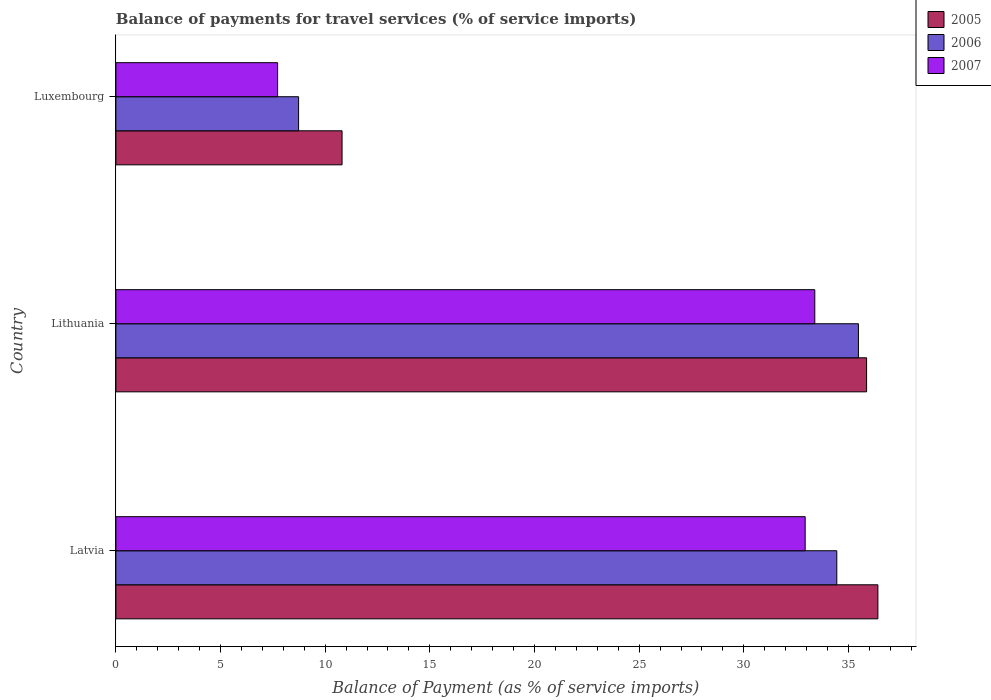How many groups of bars are there?
Your answer should be compact. 3. Are the number of bars per tick equal to the number of legend labels?
Your answer should be very brief. Yes. Are the number of bars on each tick of the Y-axis equal?
Provide a short and direct response. Yes. How many bars are there on the 2nd tick from the bottom?
Your response must be concise. 3. What is the label of the 2nd group of bars from the top?
Ensure brevity in your answer.  Lithuania. What is the balance of payments for travel services in 2005 in Luxembourg?
Provide a short and direct response. 10.81. Across all countries, what is the maximum balance of payments for travel services in 2006?
Your answer should be very brief. 35.48. Across all countries, what is the minimum balance of payments for travel services in 2005?
Provide a succinct answer. 10.81. In which country was the balance of payments for travel services in 2007 maximum?
Provide a succinct answer. Lithuania. In which country was the balance of payments for travel services in 2005 minimum?
Offer a terse response. Luxembourg. What is the total balance of payments for travel services in 2005 in the graph?
Ensure brevity in your answer.  83.08. What is the difference between the balance of payments for travel services in 2007 in Latvia and that in Luxembourg?
Offer a terse response. 25.21. What is the difference between the balance of payments for travel services in 2006 in Luxembourg and the balance of payments for travel services in 2007 in Lithuania?
Offer a very short reply. -24.66. What is the average balance of payments for travel services in 2007 per country?
Keep it short and to the point. 24.68. What is the difference between the balance of payments for travel services in 2007 and balance of payments for travel services in 2005 in Luxembourg?
Offer a very short reply. -3.08. In how many countries, is the balance of payments for travel services in 2005 greater than 3 %?
Provide a short and direct response. 3. What is the ratio of the balance of payments for travel services in 2005 in Latvia to that in Luxembourg?
Ensure brevity in your answer.  3.37. Is the balance of payments for travel services in 2005 in Latvia less than that in Luxembourg?
Offer a terse response. No. Is the difference between the balance of payments for travel services in 2007 in Latvia and Luxembourg greater than the difference between the balance of payments for travel services in 2005 in Latvia and Luxembourg?
Ensure brevity in your answer.  No. What is the difference between the highest and the second highest balance of payments for travel services in 2007?
Provide a short and direct response. 0.46. What is the difference between the highest and the lowest balance of payments for travel services in 2005?
Your answer should be very brief. 25.6. In how many countries, is the balance of payments for travel services in 2005 greater than the average balance of payments for travel services in 2005 taken over all countries?
Your answer should be very brief. 2. What does the 1st bar from the bottom in Luxembourg represents?
Your response must be concise. 2005. Is it the case that in every country, the sum of the balance of payments for travel services in 2006 and balance of payments for travel services in 2007 is greater than the balance of payments for travel services in 2005?
Keep it short and to the point. Yes. How many bars are there?
Keep it short and to the point. 9. Are all the bars in the graph horizontal?
Keep it short and to the point. Yes. How many countries are there in the graph?
Your answer should be compact. 3. What is the difference between two consecutive major ticks on the X-axis?
Give a very brief answer. 5. Are the values on the major ticks of X-axis written in scientific E-notation?
Provide a short and direct response. No. Does the graph contain any zero values?
Provide a succinct answer. No. Where does the legend appear in the graph?
Your answer should be compact. Top right. How many legend labels are there?
Offer a terse response. 3. What is the title of the graph?
Give a very brief answer. Balance of payments for travel services (% of service imports). Does "2009" appear as one of the legend labels in the graph?
Offer a terse response. No. What is the label or title of the X-axis?
Your response must be concise. Balance of Payment (as % of service imports). What is the label or title of the Y-axis?
Your answer should be compact. Country. What is the Balance of Payment (as % of service imports) of 2005 in Latvia?
Your answer should be very brief. 36.41. What is the Balance of Payment (as % of service imports) of 2006 in Latvia?
Provide a succinct answer. 34.44. What is the Balance of Payment (as % of service imports) in 2007 in Latvia?
Provide a succinct answer. 32.93. What is the Balance of Payment (as % of service imports) in 2005 in Lithuania?
Ensure brevity in your answer.  35.87. What is the Balance of Payment (as % of service imports) of 2006 in Lithuania?
Your response must be concise. 35.48. What is the Balance of Payment (as % of service imports) in 2007 in Lithuania?
Your response must be concise. 33.39. What is the Balance of Payment (as % of service imports) of 2005 in Luxembourg?
Offer a terse response. 10.81. What is the Balance of Payment (as % of service imports) in 2006 in Luxembourg?
Offer a very short reply. 8.73. What is the Balance of Payment (as % of service imports) of 2007 in Luxembourg?
Your answer should be compact. 7.73. Across all countries, what is the maximum Balance of Payment (as % of service imports) of 2005?
Provide a short and direct response. 36.41. Across all countries, what is the maximum Balance of Payment (as % of service imports) of 2006?
Ensure brevity in your answer.  35.48. Across all countries, what is the maximum Balance of Payment (as % of service imports) in 2007?
Provide a succinct answer. 33.39. Across all countries, what is the minimum Balance of Payment (as % of service imports) in 2005?
Give a very brief answer. 10.81. Across all countries, what is the minimum Balance of Payment (as % of service imports) in 2006?
Your response must be concise. 8.73. Across all countries, what is the minimum Balance of Payment (as % of service imports) in 2007?
Your answer should be very brief. 7.73. What is the total Balance of Payment (as % of service imports) of 2005 in the graph?
Keep it short and to the point. 83.08. What is the total Balance of Payment (as % of service imports) in 2006 in the graph?
Your answer should be compact. 78.65. What is the total Balance of Payment (as % of service imports) in 2007 in the graph?
Make the answer very short. 74.05. What is the difference between the Balance of Payment (as % of service imports) in 2005 in Latvia and that in Lithuania?
Offer a very short reply. 0.54. What is the difference between the Balance of Payment (as % of service imports) in 2006 in Latvia and that in Lithuania?
Give a very brief answer. -1.03. What is the difference between the Balance of Payment (as % of service imports) in 2007 in Latvia and that in Lithuania?
Offer a terse response. -0.46. What is the difference between the Balance of Payment (as % of service imports) of 2005 in Latvia and that in Luxembourg?
Your answer should be very brief. 25.6. What is the difference between the Balance of Payment (as % of service imports) of 2006 in Latvia and that in Luxembourg?
Ensure brevity in your answer.  25.71. What is the difference between the Balance of Payment (as % of service imports) in 2007 in Latvia and that in Luxembourg?
Keep it short and to the point. 25.21. What is the difference between the Balance of Payment (as % of service imports) of 2005 in Lithuania and that in Luxembourg?
Your answer should be very brief. 25.06. What is the difference between the Balance of Payment (as % of service imports) in 2006 in Lithuania and that in Luxembourg?
Ensure brevity in your answer.  26.75. What is the difference between the Balance of Payment (as % of service imports) of 2007 in Lithuania and that in Luxembourg?
Ensure brevity in your answer.  25.67. What is the difference between the Balance of Payment (as % of service imports) of 2005 in Latvia and the Balance of Payment (as % of service imports) of 2007 in Lithuania?
Keep it short and to the point. 3.01. What is the difference between the Balance of Payment (as % of service imports) of 2006 in Latvia and the Balance of Payment (as % of service imports) of 2007 in Lithuania?
Your response must be concise. 1.05. What is the difference between the Balance of Payment (as % of service imports) of 2005 in Latvia and the Balance of Payment (as % of service imports) of 2006 in Luxembourg?
Keep it short and to the point. 27.68. What is the difference between the Balance of Payment (as % of service imports) of 2005 in Latvia and the Balance of Payment (as % of service imports) of 2007 in Luxembourg?
Your answer should be very brief. 28.68. What is the difference between the Balance of Payment (as % of service imports) of 2006 in Latvia and the Balance of Payment (as % of service imports) of 2007 in Luxembourg?
Make the answer very short. 26.72. What is the difference between the Balance of Payment (as % of service imports) of 2005 in Lithuania and the Balance of Payment (as % of service imports) of 2006 in Luxembourg?
Ensure brevity in your answer.  27.14. What is the difference between the Balance of Payment (as % of service imports) of 2005 in Lithuania and the Balance of Payment (as % of service imports) of 2007 in Luxembourg?
Offer a very short reply. 28.14. What is the difference between the Balance of Payment (as % of service imports) of 2006 in Lithuania and the Balance of Payment (as % of service imports) of 2007 in Luxembourg?
Ensure brevity in your answer.  27.75. What is the average Balance of Payment (as % of service imports) in 2005 per country?
Provide a succinct answer. 27.69. What is the average Balance of Payment (as % of service imports) in 2006 per country?
Your answer should be compact. 26.22. What is the average Balance of Payment (as % of service imports) of 2007 per country?
Your answer should be very brief. 24.68. What is the difference between the Balance of Payment (as % of service imports) in 2005 and Balance of Payment (as % of service imports) in 2006 in Latvia?
Your response must be concise. 1.96. What is the difference between the Balance of Payment (as % of service imports) in 2005 and Balance of Payment (as % of service imports) in 2007 in Latvia?
Give a very brief answer. 3.47. What is the difference between the Balance of Payment (as % of service imports) of 2006 and Balance of Payment (as % of service imports) of 2007 in Latvia?
Give a very brief answer. 1.51. What is the difference between the Balance of Payment (as % of service imports) in 2005 and Balance of Payment (as % of service imports) in 2006 in Lithuania?
Offer a very short reply. 0.39. What is the difference between the Balance of Payment (as % of service imports) in 2005 and Balance of Payment (as % of service imports) in 2007 in Lithuania?
Offer a terse response. 2.47. What is the difference between the Balance of Payment (as % of service imports) in 2006 and Balance of Payment (as % of service imports) in 2007 in Lithuania?
Provide a short and direct response. 2.08. What is the difference between the Balance of Payment (as % of service imports) in 2005 and Balance of Payment (as % of service imports) in 2006 in Luxembourg?
Your response must be concise. 2.08. What is the difference between the Balance of Payment (as % of service imports) in 2005 and Balance of Payment (as % of service imports) in 2007 in Luxembourg?
Your answer should be very brief. 3.08. What is the ratio of the Balance of Payment (as % of service imports) in 2006 in Latvia to that in Lithuania?
Make the answer very short. 0.97. What is the ratio of the Balance of Payment (as % of service imports) of 2007 in Latvia to that in Lithuania?
Ensure brevity in your answer.  0.99. What is the ratio of the Balance of Payment (as % of service imports) of 2005 in Latvia to that in Luxembourg?
Your answer should be compact. 3.37. What is the ratio of the Balance of Payment (as % of service imports) in 2006 in Latvia to that in Luxembourg?
Your response must be concise. 3.95. What is the ratio of the Balance of Payment (as % of service imports) of 2007 in Latvia to that in Luxembourg?
Your answer should be very brief. 4.26. What is the ratio of the Balance of Payment (as % of service imports) in 2005 in Lithuania to that in Luxembourg?
Make the answer very short. 3.32. What is the ratio of the Balance of Payment (as % of service imports) of 2006 in Lithuania to that in Luxembourg?
Your answer should be compact. 4.06. What is the ratio of the Balance of Payment (as % of service imports) of 2007 in Lithuania to that in Luxembourg?
Keep it short and to the point. 4.32. What is the difference between the highest and the second highest Balance of Payment (as % of service imports) of 2005?
Offer a terse response. 0.54. What is the difference between the highest and the second highest Balance of Payment (as % of service imports) of 2006?
Your answer should be compact. 1.03. What is the difference between the highest and the second highest Balance of Payment (as % of service imports) of 2007?
Your response must be concise. 0.46. What is the difference between the highest and the lowest Balance of Payment (as % of service imports) of 2005?
Provide a succinct answer. 25.6. What is the difference between the highest and the lowest Balance of Payment (as % of service imports) of 2006?
Your response must be concise. 26.75. What is the difference between the highest and the lowest Balance of Payment (as % of service imports) in 2007?
Your response must be concise. 25.67. 